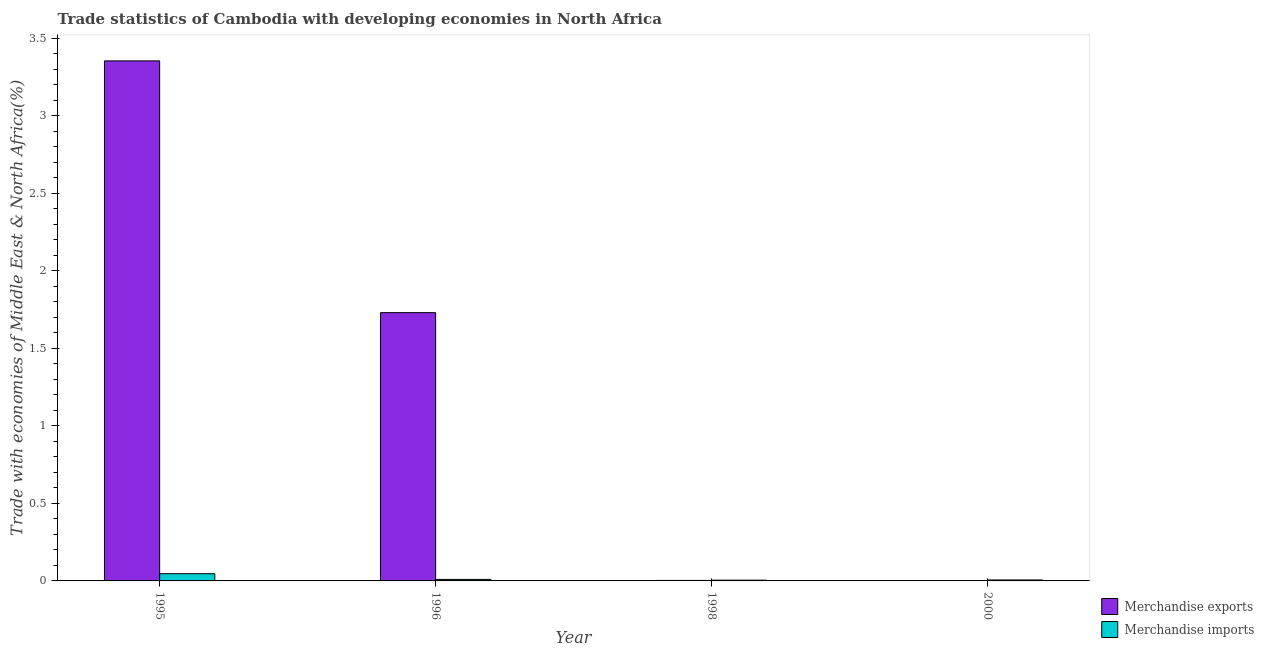How many different coloured bars are there?
Provide a succinct answer. 2. How many groups of bars are there?
Keep it short and to the point. 4. Are the number of bars per tick equal to the number of legend labels?
Your response must be concise. Yes. How many bars are there on the 4th tick from the left?
Provide a short and direct response. 2. How many bars are there on the 1st tick from the right?
Your answer should be very brief. 2. What is the label of the 3rd group of bars from the left?
Your answer should be very brief. 1998. What is the merchandise exports in 1998?
Give a very brief answer. 0. Across all years, what is the maximum merchandise exports?
Provide a short and direct response. 3.35. Across all years, what is the minimum merchandise exports?
Ensure brevity in your answer.  0. In which year was the merchandise exports minimum?
Your answer should be very brief. 2000. What is the total merchandise imports in the graph?
Offer a very short reply. 0.07. What is the difference between the merchandise imports in 1995 and that in 1996?
Provide a succinct answer. 0.04. What is the difference between the merchandise imports in 1996 and the merchandise exports in 1998?
Provide a succinct answer. 0.01. What is the average merchandise exports per year?
Your answer should be compact. 1.27. In the year 2000, what is the difference between the merchandise imports and merchandise exports?
Your response must be concise. 0. In how many years, is the merchandise imports greater than 3.3 %?
Make the answer very short. 0. What is the ratio of the merchandise imports in 1996 to that in 1998?
Offer a very short reply. 2.04. Is the merchandise imports in 1995 less than that in 2000?
Offer a very short reply. No. Is the difference between the merchandise exports in 1998 and 2000 greater than the difference between the merchandise imports in 1998 and 2000?
Give a very brief answer. No. What is the difference between the highest and the second highest merchandise imports?
Provide a short and direct response. 0.04. What is the difference between the highest and the lowest merchandise exports?
Your answer should be very brief. 3.35. Is the sum of the merchandise exports in 1995 and 2000 greater than the maximum merchandise imports across all years?
Your answer should be very brief. Yes. What does the 1st bar from the left in 1998 represents?
Offer a very short reply. Merchandise exports. What does the 1st bar from the right in 1996 represents?
Offer a terse response. Merchandise imports. How many bars are there?
Keep it short and to the point. 8. Are all the bars in the graph horizontal?
Provide a short and direct response. No. Does the graph contain any zero values?
Give a very brief answer. No. Where does the legend appear in the graph?
Provide a short and direct response. Bottom right. How many legend labels are there?
Offer a terse response. 2. How are the legend labels stacked?
Ensure brevity in your answer.  Vertical. What is the title of the graph?
Your answer should be very brief. Trade statistics of Cambodia with developing economies in North Africa. Does "Public credit registry" appear as one of the legend labels in the graph?
Your response must be concise. No. What is the label or title of the X-axis?
Your response must be concise. Year. What is the label or title of the Y-axis?
Offer a very short reply. Trade with economies of Middle East & North Africa(%). What is the Trade with economies of Middle East & North Africa(%) in Merchandise exports in 1995?
Make the answer very short. 3.35. What is the Trade with economies of Middle East & North Africa(%) of Merchandise imports in 1995?
Provide a succinct answer. 0.05. What is the Trade with economies of Middle East & North Africa(%) of Merchandise exports in 1996?
Make the answer very short. 1.73. What is the Trade with economies of Middle East & North Africa(%) in Merchandise imports in 1996?
Make the answer very short. 0.01. What is the Trade with economies of Middle East & North Africa(%) of Merchandise exports in 1998?
Your answer should be compact. 0. What is the Trade with economies of Middle East & North Africa(%) in Merchandise imports in 1998?
Make the answer very short. 0. What is the Trade with economies of Middle East & North Africa(%) of Merchandise exports in 2000?
Keep it short and to the point. 0. What is the Trade with economies of Middle East & North Africa(%) in Merchandise imports in 2000?
Provide a succinct answer. 0.01. Across all years, what is the maximum Trade with economies of Middle East & North Africa(%) of Merchandise exports?
Provide a succinct answer. 3.35. Across all years, what is the maximum Trade with economies of Middle East & North Africa(%) in Merchandise imports?
Make the answer very short. 0.05. Across all years, what is the minimum Trade with economies of Middle East & North Africa(%) of Merchandise exports?
Ensure brevity in your answer.  0. Across all years, what is the minimum Trade with economies of Middle East & North Africa(%) of Merchandise imports?
Offer a terse response. 0. What is the total Trade with economies of Middle East & North Africa(%) of Merchandise exports in the graph?
Your response must be concise. 5.09. What is the total Trade with economies of Middle East & North Africa(%) of Merchandise imports in the graph?
Offer a terse response. 0.07. What is the difference between the Trade with economies of Middle East & North Africa(%) in Merchandise exports in 1995 and that in 1996?
Your answer should be compact. 1.62. What is the difference between the Trade with economies of Middle East & North Africa(%) in Merchandise imports in 1995 and that in 1996?
Ensure brevity in your answer.  0.04. What is the difference between the Trade with economies of Middle East & North Africa(%) of Merchandise exports in 1995 and that in 1998?
Your response must be concise. 3.35. What is the difference between the Trade with economies of Middle East & North Africa(%) of Merchandise imports in 1995 and that in 1998?
Your answer should be compact. 0.04. What is the difference between the Trade with economies of Middle East & North Africa(%) in Merchandise exports in 1995 and that in 2000?
Give a very brief answer. 3.35. What is the difference between the Trade with economies of Middle East & North Africa(%) of Merchandise imports in 1995 and that in 2000?
Provide a succinct answer. 0.04. What is the difference between the Trade with economies of Middle East & North Africa(%) of Merchandise exports in 1996 and that in 1998?
Your answer should be very brief. 1.73. What is the difference between the Trade with economies of Middle East & North Africa(%) in Merchandise imports in 1996 and that in 1998?
Keep it short and to the point. 0.01. What is the difference between the Trade with economies of Middle East & North Africa(%) of Merchandise exports in 1996 and that in 2000?
Keep it short and to the point. 1.73. What is the difference between the Trade with economies of Middle East & North Africa(%) in Merchandise imports in 1996 and that in 2000?
Your answer should be compact. 0. What is the difference between the Trade with economies of Middle East & North Africa(%) in Merchandise exports in 1998 and that in 2000?
Keep it short and to the point. 0. What is the difference between the Trade with economies of Middle East & North Africa(%) in Merchandise imports in 1998 and that in 2000?
Your answer should be very brief. -0. What is the difference between the Trade with economies of Middle East & North Africa(%) in Merchandise exports in 1995 and the Trade with economies of Middle East & North Africa(%) in Merchandise imports in 1996?
Keep it short and to the point. 3.34. What is the difference between the Trade with economies of Middle East & North Africa(%) of Merchandise exports in 1995 and the Trade with economies of Middle East & North Africa(%) of Merchandise imports in 1998?
Provide a short and direct response. 3.35. What is the difference between the Trade with economies of Middle East & North Africa(%) of Merchandise exports in 1995 and the Trade with economies of Middle East & North Africa(%) of Merchandise imports in 2000?
Your answer should be very brief. 3.35. What is the difference between the Trade with economies of Middle East & North Africa(%) of Merchandise exports in 1996 and the Trade with economies of Middle East & North Africa(%) of Merchandise imports in 1998?
Offer a very short reply. 1.73. What is the difference between the Trade with economies of Middle East & North Africa(%) of Merchandise exports in 1996 and the Trade with economies of Middle East & North Africa(%) of Merchandise imports in 2000?
Your response must be concise. 1.72. What is the difference between the Trade with economies of Middle East & North Africa(%) of Merchandise exports in 1998 and the Trade with economies of Middle East & North Africa(%) of Merchandise imports in 2000?
Your response must be concise. -0. What is the average Trade with economies of Middle East & North Africa(%) in Merchandise exports per year?
Your answer should be very brief. 1.27. What is the average Trade with economies of Middle East & North Africa(%) in Merchandise imports per year?
Make the answer very short. 0.02. In the year 1995, what is the difference between the Trade with economies of Middle East & North Africa(%) of Merchandise exports and Trade with economies of Middle East & North Africa(%) of Merchandise imports?
Offer a terse response. 3.31. In the year 1996, what is the difference between the Trade with economies of Middle East & North Africa(%) of Merchandise exports and Trade with economies of Middle East & North Africa(%) of Merchandise imports?
Your response must be concise. 1.72. In the year 1998, what is the difference between the Trade with economies of Middle East & North Africa(%) in Merchandise exports and Trade with economies of Middle East & North Africa(%) in Merchandise imports?
Provide a short and direct response. -0. In the year 2000, what is the difference between the Trade with economies of Middle East & North Africa(%) of Merchandise exports and Trade with economies of Middle East & North Africa(%) of Merchandise imports?
Ensure brevity in your answer.  -0. What is the ratio of the Trade with economies of Middle East & North Africa(%) of Merchandise exports in 1995 to that in 1996?
Give a very brief answer. 1.94. What is the ratio of the Trade with economies of Middle East & North Africa(%) of Merchandise imports in 1995 to that in 1996?
Your answer should be compact. 4.73. What is the ratio of the Trade with economies of Middle East & North Africa(%) in Merchandise exports in 1995 to that in 1998?
Provide a succinct answer. 1043.42. What is the ratio of the Trade with economies of Middle East & North Africa(%) of Merchandise imports in 1995 to that in 1998?
Ensure brevity in your answer.  9.66. What is the ratio of the Trade with economies of Middle East & North Africa(%) in Merchandise exports in 1995 to that in 2000?
Offer a terse response. 1280.85. What is the ratio of the Trade with economies of Middle East & North Africa(%) in Merchandise imports in 1995 to that in 2000?
Make the answer very short. 7.54. What is the ratio of the Trade with economies of Middle East & North Africa(%) of Merchandise exports in 1996 to that in 1998?
Offer a very short reply. 538.26. What is the ratio of the Trade with economies of Middle East & North Africa(%) in Merchandise imports in 1996 to that in 1998?
Offer a terse response. 2.04. What is the ratio of the Trade with economies of Middle East & North Africa(%) of Merchandise exports in 1996 to that in 2000?
Provide a succinct answer. 660.75. What is the ratio of the Trade with economies of Middle East & North Africa(%) in Merchandise imports in 1996 to that in 2000?
Offer a very short reply. 1.59. What is the ratio of the Trade with economies of Middle East & North Africa(%) in Merchandise exports in 1998 to that in 2000?
Make the answer very short. 1.23. What is the ratio of the Trade with economies of Middle East & North Africa(%) in Merchandise imports in 1998 to that in 2000?
Offer a very short reply. 0.78. What is the difference between the highest and the second highest Trade with economies of Middle East & North Africa(%) of Merchandise exports?
Your answer should be compact. 1.62. What is the difference between the highest and the second highest Trade with economies of Middle East & North Africa(%) in Merchandise imports?
Offer a very short reply. 0.04. What is the difference between the highest and the lowest Trade with economies of Middle East & North Africa(%) in Merchandise exports?
Offer a very short reply. 3.35. What is the difference between the highest and the lowest Trade with economies of Middle East & North Africa(%) of Merchandise imports?
Your answer should be compact. 0.04. 